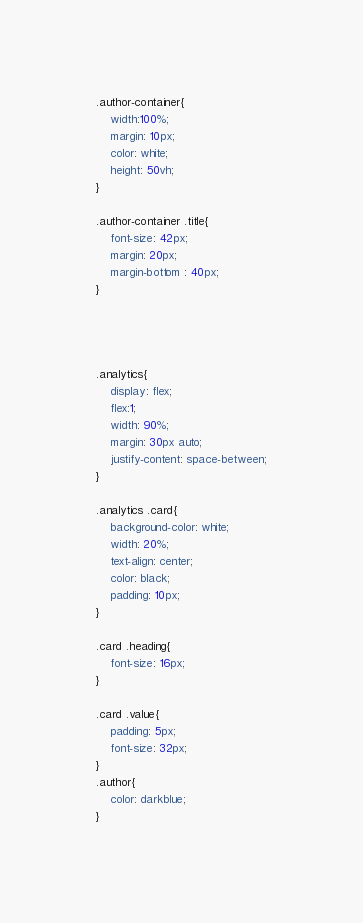<code> <loc_0><loc_0><loc_500><loc_500><_CSS_>.author-container{
    width:100%;
    margin: 10px;  
    color: white;
    height: 50vh;
}

.author-container .title{
    font-size: 42px;
    margin: 20px;
    margin-bottom : 40px;
}




.analytics{
    display: flex;
    flex:1;
    width: 90%;
    margin: 30px auto;
    justify-content: space-between;
}

.analytics .card{
    background-color: white;
    width: 20%;
    text-align: center;
    color: black;
    padding: 10px;
}

.card .heading{
    font-size: 16px;
}

.card .value{
    padding: 5px;
    font-size: 32px;
}
.author{
    color: darkblue;
}
</code> 